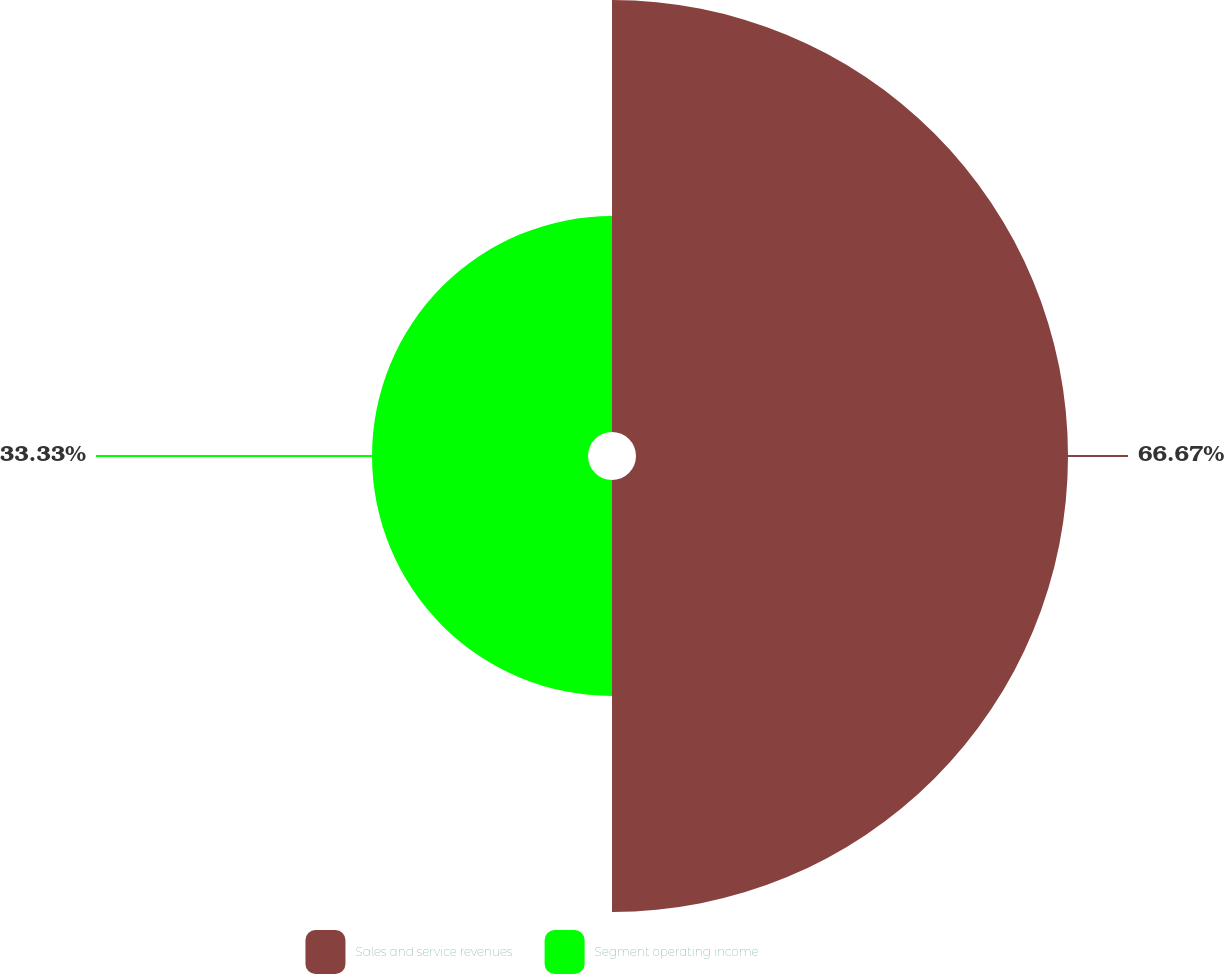<chart> <loc_0><loc_0><loc_500><loc_500><pie_chart><fcel>Sales and service revenues<fcel>Segment operating income<nl><fcel>66.67%<fcel>33.33%<nl></chart> 